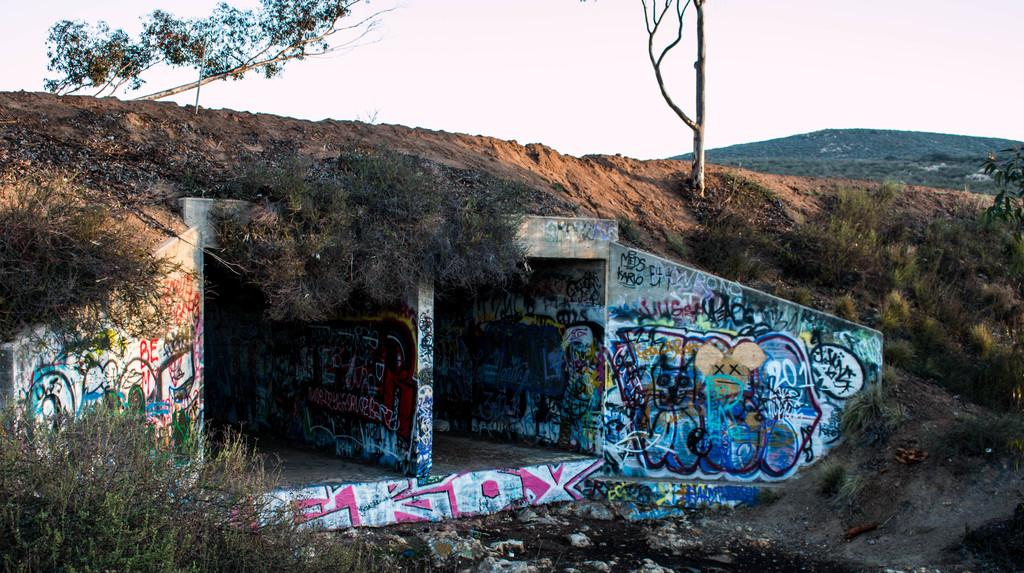<image>
Summarize the visual content of the image. A concrete tunnel in a hillside that has lots of grafitti including the word GRIOX. 